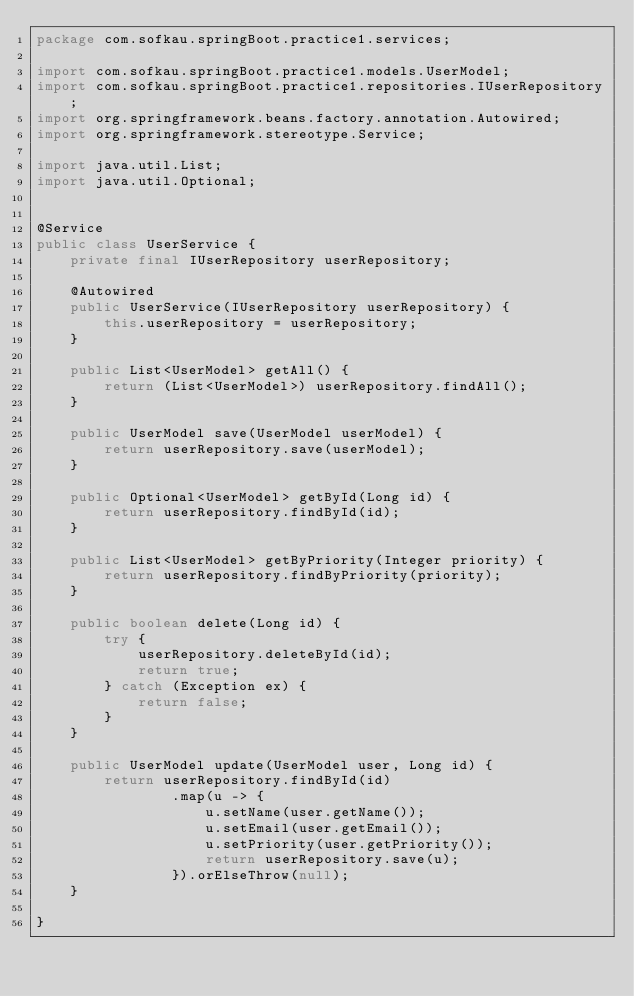Convert code to text. <code><loc_0><loc_0><loc_500><loc_500><_Java_>package com.sofkau.springBoot.practice1.services;

import com.sofkau.springBoot.practice1.models.UserModel;
import com.sofkau.springBoot.practice1.repositories.IUserRepository;
import org.springframework.beans.factory.annotation.Autowired;
import org.springframework.stereotype.Service;

import java.util.List;
import java.util.Optional;


@Service
public class UserService {
    private final IUserRepository userRepository;

    @Autowired
    public UserService(IUserRepository userRepository) {
        this.userRepository = userRepository;
    }

    public List<UserModel> getAll() {
        return (List<UserModel>) userRepository.findAll();
    }

    public UserModel save(UserModel userModel) {
        return userRepository.save(userModel);
    }

    public Optional<UserModel> getById(Long id) {
        return userRepository.findById(id);
    }

    public List<UserModel> getByPriority(Integer priority) {
        return userRepository.findByPriority(priority);
    }

    public boolean delete(Long id) {
        try {
            userRepository.deleteById(id);
            return true;
        } catch (Exception ex) {
            return false;
        }
    }

    public UserModel update(UserModel user, Long id) {
        return userRepository.findById(id)
                .map(u -> {
                    u.setName(user.getName());
                    u.setEmail(user.getEmail());
                    u.setPriority(user.getPriority());
                    return userRepository.save(u);
                }).orElseThrow(null);
    }

}
</code> 